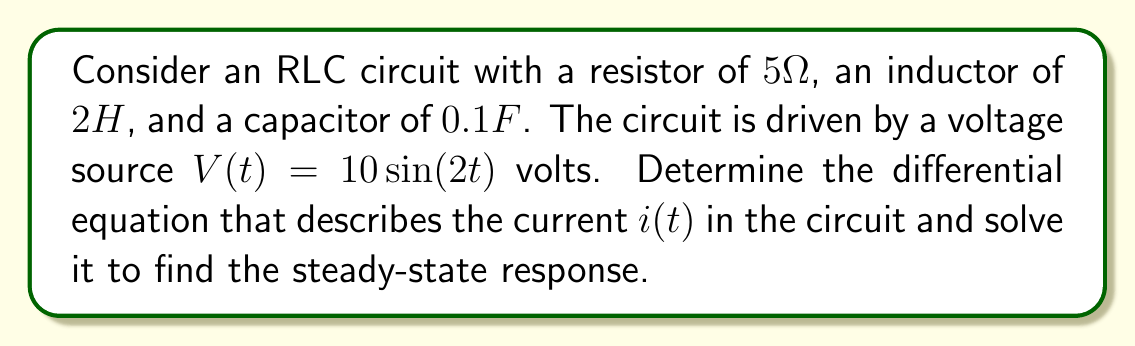Teach me how to tackle this problem. To solve this problem, we'll follow these steps:

1) First, we need to set up the differential equation for the RLC circuit:

   $$L\frac{d^2i}{dt^2} + R\frac{di}{dt} + \frac{1}{C}i = V(t)$$

   Where $L$ is inductance, $R$ is resistance, $C$ is capacitance, and $V(t)$ is the voltage source.

2) Substituting the given values:

   $$2\frac{d^2i}{dt^2} + 5\frac{di}{dt} + 10i = 10\sin(2t)$$

3) This is a non-homogeneous second-order linear differential equation. The steady-state solution will have the form:

   $$i(t) = A\sin(2t) + B\cos(2t)$$

4) To find $A$ and $B$, we need to substitute this solution into the differential equation:

   $$2(-4A\sin(2t) - 4B\cos(2t)) + 5(2A\cos(2t) - 2B\sin(2t)) + 10(A\sin(2t) + B\cos(2t)) = 10\sin(2t)$$

5) Collecting $\sin(2t)$ and $\cos(2t)$ terms:

   $$(-8A + 10A - 10B)\sin(2t) + (-8B + 10A + 10B)\cos(2t) = 10\sin(2t)$$

6) Equating coefficients:

   $$2A - 10B = 10$$
   $$10A + 2B = 0$$

7) Solving this system of equations:

   $$A = \frac{20}{104} = \frac{5}{26}, B = -\frac{50}{104} = -\frac{25}{52}$$

8) Therefore, the steady-state solution is:

   $$i(t) = \frac{5}{26}\sin(2t) - \frac{25}{52}\cos(2t)$$
Answer: The steady-state current in the circuit is:

$$i(t) = \frac{5}{26}\sin(2t) - \frac{25}{52}\cos(2t)$$ 